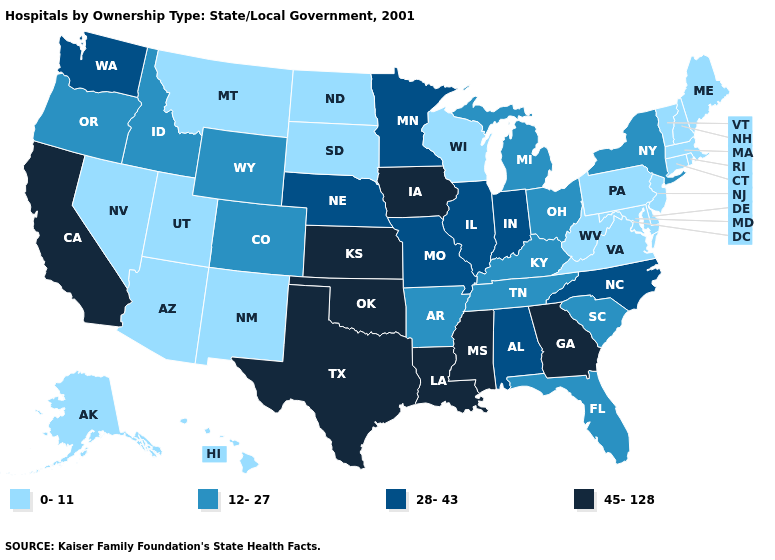What is the lowest value in states that border Nebraska?
Answer briefly. 0-11. How many symbols are there in the legend?
Be succinct. 4. What is the value of West Virginia?
Answer briefly. 0-11. What is the lowest value in the USA?
Quick response, please. 0-11. Name the states that have a value in the range 28-43?
Be succinct. Alabama, Illinois, Indiana, Minnesota, Missouri, Nebraska, North Carolina, Washington. What is the highest value in the USA?
Quick response, please. 45-128. Is the legend a continuous bar?
Give a very brief answer. No. Does Utah have a lower value than Maine?
Answer briefly. No. Name the states that have a value in the range 28-43?
Short answer required. Alabama, Illinois, Indiana, Minnesota, Missouri, Nebraska, North Carolina, Washington. Name the states that have a value in the range 28-43?
Give a very brief answer. Alabama, Illinois, Indiana, Minnesota, Missouri, Nebraska, North Carolina, Washington. What is the value of Missouri?
Give a very brief answer. 28-43. Among the states that border Alabama , which have the lowest value?
Short answer required. Florida, Tennessee. Does Colorado have the lowest value in the West?
Write a very short answer. No. Name the states that have a value in the range 45-128?
Short answer required. California, Georgia, Iowa, Kansas, Louisiana, Mississippi, Oklahoma, Texas. Name the states that have a value in the range 0-11?
Keep it brief. Alaska, Arizona, Connecticut, Delaware, Hawaii, Maine, Maryland, Massachusetts, Montana, Nevada, New Hampshire, New Jersey, New Mexico, North Dakota, Pennsylvania, Rhode Island, South Dakota, Utah, Vermont, Virginia, West Virginia, Wisconsin. 